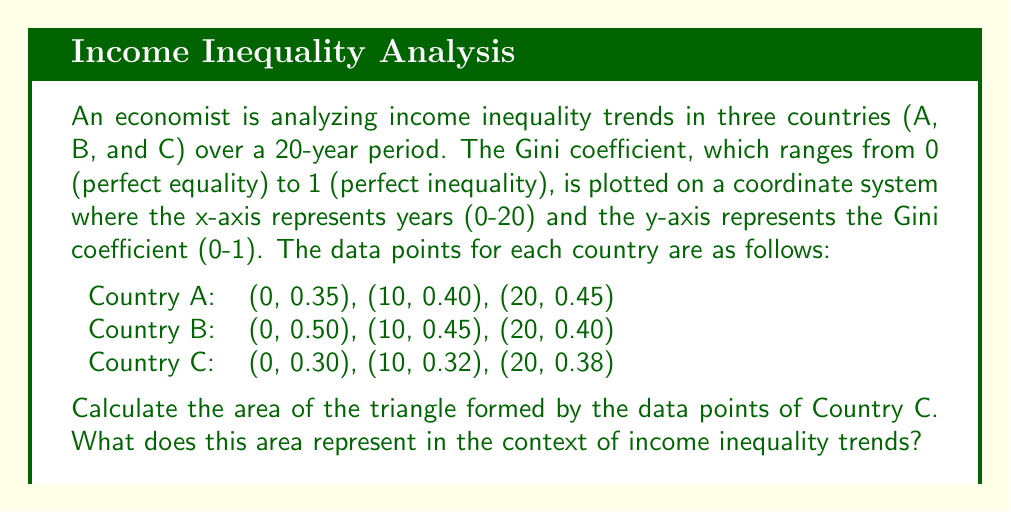Can you answer this question? To solve this problem, we need to follow these steps:

1. Plot the points for Country C on the coordinate system.
2. Calculate the area of the triangle formed by these points.
3. Interpret the meaning of this area in the context of income inequality trends.

Step 1: Plotting the points
The points for Country C are (0, 0.30), (10, 0.32), and (20, 0.38).

Step 2: Calculating the area of the triangle
To calculate the area of a triangle given three points, we can use the formula:

$$ Area = \frac{1}{2}|x_1(y_2 - y_3) + x_2(y_3 - y_1) + x_3(y_1 - y_2)| $$

Where $(x_1, y_1)$, $(x_2, y_2)$, and $(x_3, y_3)$ are the coordinates of the three points.

Substituting our values:

$$ \begin{align*}
Area &= \frac{1}{2}|0(0.32 - 0.38) + 10(0.38 - 0.30) + 20(0.30 - 0.32)| \\
&= \frac{1}{2}|0(-0.06) + 10(0.08) + 20(-0.02)| \\
&= \frac{1}{2}|0 + 0.8 - 0.4| \\
&= \frac{1}{2}(0.4) \\
&= 0.2
\end{align*} $$

Step 3: Interpreting the result
The area of the triangle represents the overall change in income inequality for Country C over the 20-year period. A larger area would indicate more significant changes in inequality, while a smaller area would suggest more stable inequality levels.

In this case, the area of 0.2 indicates a moderate increase in income inequality for Country C. The positive area suggests that inequality has grown over time, as we can see from the increasing Gini coefficient values (0.30 to 0.38).
Answer: The area of the triangle formed by Country C's data points is 0.2. This represents a moderate increase in income inequality over the 20-year period, with the positive area indicating a growing trend in inequality for Country C. 